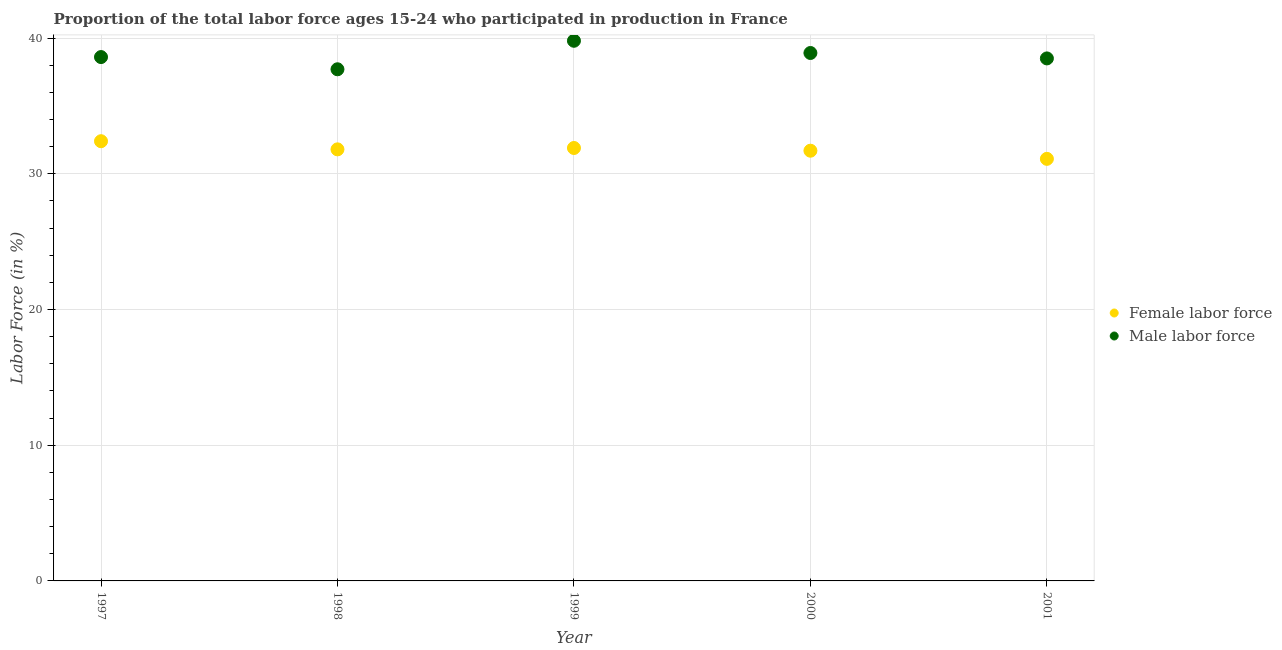Is the number of dotlines equal to the number of legend labels?
Offer a terse response. Yes. What is the percentage of female labor force in 2001?
Offer a terse response. 31.1. Across all years, what is the maximum percentage of male labour force?
Provide a succinct answer. 39.8. Across all years, what is the minimum percentage of female labor force?
Your response must be concise. 31.1. In which year was the percentage of female labor force minimum?
Your answer should be compact. 2001. What is the total percentage of male labour force in the graph?
Offer a very short reply. 193.5. What is the difference between the percentage of female labor force in 1999 and that in 2001?
Keep it short and to the point. 0.8. What is the difference between the percentage of male labour force in 2001 and the percentage of female labor force in 1998?
Make the answer very short. 6.7. What is the average percentage of female labor force per year?
Offer a very short reply. 31.78. In the year 2000, what is the difference between the percentage of male labour force and percentage of female labor force?
Offer a very short reply. 7.2. What is the ratio of the percentage of female labor force in 1997 to that in 2001?
Your answer should be compact. 1.04. Is the percentage of female labor force in 1997 less than that in 1998?
Your answer should be very brief. No. What is the difference between the highest and the second highest percentage of male labour force?
Offer a terse response. 0.9. What is the difference between the highest and the lowest percentage of female labor force?
Your answer should be very brief. 1.3. Is the percentage of male labour force strictly less than the percentage of female labor force over the years?
Ensure brevity in your answer.  No. How many dotlines are there?
Make the answer very short. 2. How many years are there in the graph?
Give a very brief answer. 5. Does the graph contain grids?
Ensure brevity in your answer.  Yes. How many legend labels are there?
Make the answer very short. 2. How are the legend labels stacked?
Give a very brief answer. Vertical. What is the title of the graph?
Provide a succinct answer. Proportion of the total labor force ages 15-24 who participated in production in France. What is the label or title of the Y-axis?
Make the answer very short. Labor Force (in %). What is the Labor Force (in %) in Female labor force in 1997?
Provide a short and direct response. 32.4. What is the Labor Force (in %) of Male labor force in 1997?
Ensure brevity in your answer.  38.6. What is the Labor Force (in %) in Female labor force in 1998?
Provide a succinct answer. 31.8. What is the Labor Force (in %) of Male labor force in 1998?
Your answer should be very brief. 37.7. What is the Labor Force (in %) of Female labor force in 1999?
Give a very brief answer. 31.9. What is the Labor Force (in %) of Male labor force in 1999?
Ensure brevity in your answer.  39.8. What is the Labor Force (in %) of Female labor force in 2000?
Offer a terse response. 31.7. What is the Labor Force (in %) of Male labor force in 2000?
Make the answer very short. 38.9. What is the Labor Force (in %) in Female labor force in 2001?
Offer a very short reply. 31.1. What is the Labor Force (in %) of Male labor force in 2001?
Your answer should be compact. 38.5. Across all years, what is the maximum Labor Force (in %) of Female labor force?
Offer a terse response. 32.4. Across all years, what is the maximum Labor Force (in %) of Male labor force?
Give a very brief answer. 39.8. Across all years, what is the minimum Labor Force (in %) in Female labor force?
Your answer should be compact. 31.1. Across all years, what is the minimum Labor Force (in %) in Male labor force?
Your answer should be compact. 37.7. What is the total Labor Force (in %) in Female labor force in the graph?
Ensure brevity in your answer.  158.9. What is the total Labor Force (in %) in Male labor force in the graph?
Your answer should be very brief. 193.5. What is the difference between the Labor Force (in %) in Female labor force in 1997 and that in 1998?
Provide a short and direct response. 0.6. What is the difference between the Labor Force (in %) of Male labor force in 1997 and that in 1998?
Your response must be concise. 0.9. What is the difference between the Labor Force (in %) of Male labor force in 1997 and that in 1999?
Your response must be concise. -1.2. What is the difference between the Labor Force (in %) in Male labor force in 1997 and that in 2000?
Keep it short and to the point. -0.3. What is the difference between the Labor Force (in %) in Female labor force in 1999 and that in 2000?
Give a very brief answer. 0.2. What is the difference between the Labor Force (in %) of Female labor force in 1997 and the Labor Force (in %) of Male labor force in 1998?
Offer a terse response. -5.3. What is the difference between the Labor Force (in %) of Female labor force in 1997 and the Labor Force (in %) of Male labor force in 2001?
Provide a short and direct response. -6.1. What is the difference between the Labor Force (in %) of Female labor force in 1999 and the Labor Force (in %) of Male labor force in 2000?
Provide a short and direct response. -7. What is the difference between the Labor Force (in %) in Female labor force in 1999 and the Labor Force (in %) in Male labor force in 2001?
Provide a short and direct response. -6.6. What is the difference between the Labor Force (in %) of Female labor force in 2000 and the Labor Force (in %) of Male labor force in 2001?
Your answer should be compact. -6.8. What is the average Labor Force (in %) of Female labor force per year?
Your answer should be very brief. 31.78. What is the average Labor Force (in %) in Male labor force per year?
Offer a very short reply. 38.7. In the year 1997, what is the difference between the Labor Force (in %) in Female labor force and Labor Force (in %) in Male labor force?
Offer a terse response. -6.2. In the year 1999, what is the difference between the Labor Force (in %) of Female labor force and Labor Force (in %) of Male labor force?
Provide a short and direct response. -7.9. In the year 2000, what is the difference between the Labor Force (in %) in Female labor force and Labor Force (in %) in Male labor force?
Your response must be concise. -7.2. In the year 2001, what is the difference between the Labor Force (in %) of Female labor force and Labor Force (in %) of Male labor force?
Offer a very short reply. -7.4. What is the ratio of the Labor Force (in %) in Female labor force in 1997 to that in 1998?
Provide a succinct answer. 1.02. What is the ratio of the Labor Force (in %) of Male labor force in 1997 to that in 1998?
Make the answer very short. 1.02. What is the ratio of the Labor Force (in %) of Female labor force in 1997 to that in 1999?
Give a very brief answer. 1.02. What is the ratio of the Labor Force (in %) in Male labor force in 1997 to that in 1999?
Provide a succinct answer. 0.97. What is the ratio of the Labor Force (in %) of Female labor force in 1997 to that in 2000?
Make the answer very short. 1.02. What is the ratio of the Labor Force (in %) in Female labor force in 1997 to that in 2001?
Offer a terse response. 1.04. What is the ratio of the Labor Force (in %) in Male labor force in 1997 to that in 2001?
Keep it short and to the point. 1. What is the ratio of the Labor Force (in %) in Male labor force in 1998 to that in 1999?
Your answer should be very brief. 0.95. What is the ratio of the Labor Force (in %) of Female labor force in 1998 to that in 2000?
Your answer should be compact. 1. What is the ratio of the Labor Force (in %) of Male labor force in 1998 to that in 2000?
Offer a very short reply. 0.97. What is the ratio of the Labor Force (in %) in Female labor force in 1998 to that in 2001?
Keep it short and to the point. 1.02. What is the ratio of the Labor Force (in %) of Male labor force in 1998 to that in 2001?
Offer a very short reply. 0.98. What is the ratio of the Labor Force (in %) in Female labor force in 1999 to that in 2000?
Provide a succinct answer. 1.01. What is the ratio of the Labor Force (in %) of Male labor force in 1999 to that in 2000?
Your response must be concise. 1.02. What is the ratio of the Labor Force (in %) of Female labor force in 1999 to that in 2001?
Offer a terse response. 1.03. What is the ratio of the Labor Force (in %) of Male labor force in 1999 to that in 2001?
Ensure brevity in your answer.  1.03. What is the ratio of the Labor Force (in %) of Female labor force in 2000 to that in 2001?
Your answer should be very brief. 1.02. What is the ratio of the Labor Force (in %) in Male labor force in 2000 to that in 2001?
Offer a terse response. 1.01. What is the difference between the highest and the second highest Labor Force (in %) of Female labor force?
Keep it short and to the point. 0.5. What is the difference between the highest and the lowest Labor Force (in %) in Male labor force?
Your answer should be compact. 2.1. 